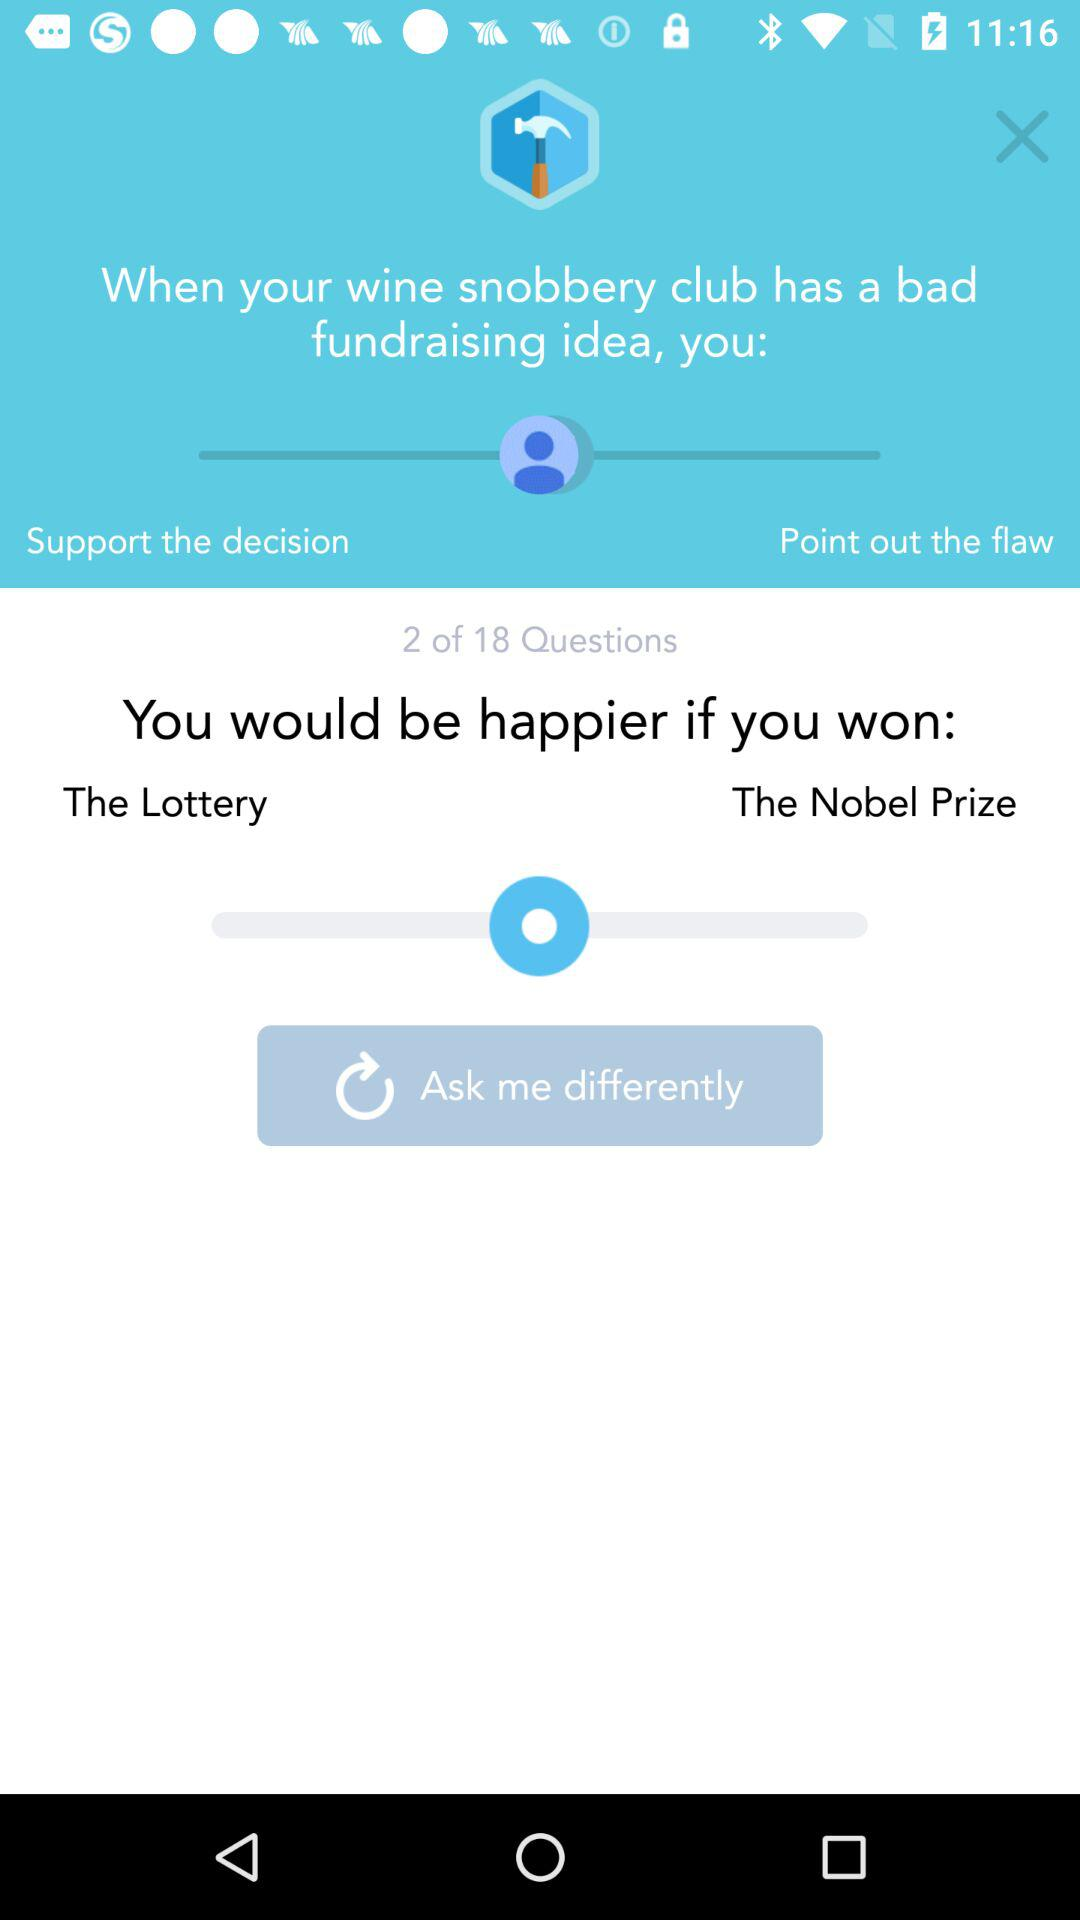At which question am I? You are at the second question. 